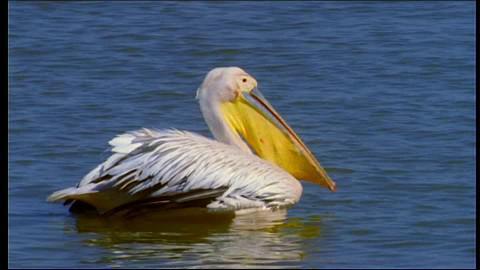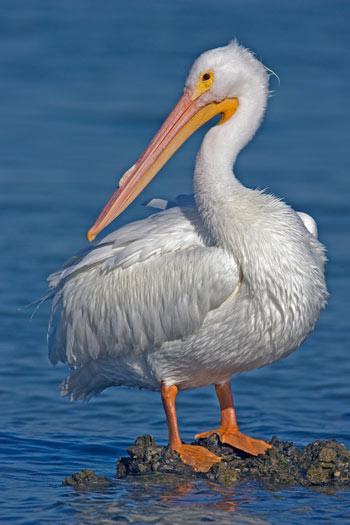The first image is the image on the left, the second image is the image on the right. Examine the images to the left and right. Is the description "All of the birds are facing the right." accurate? Answer yes or no. No. 